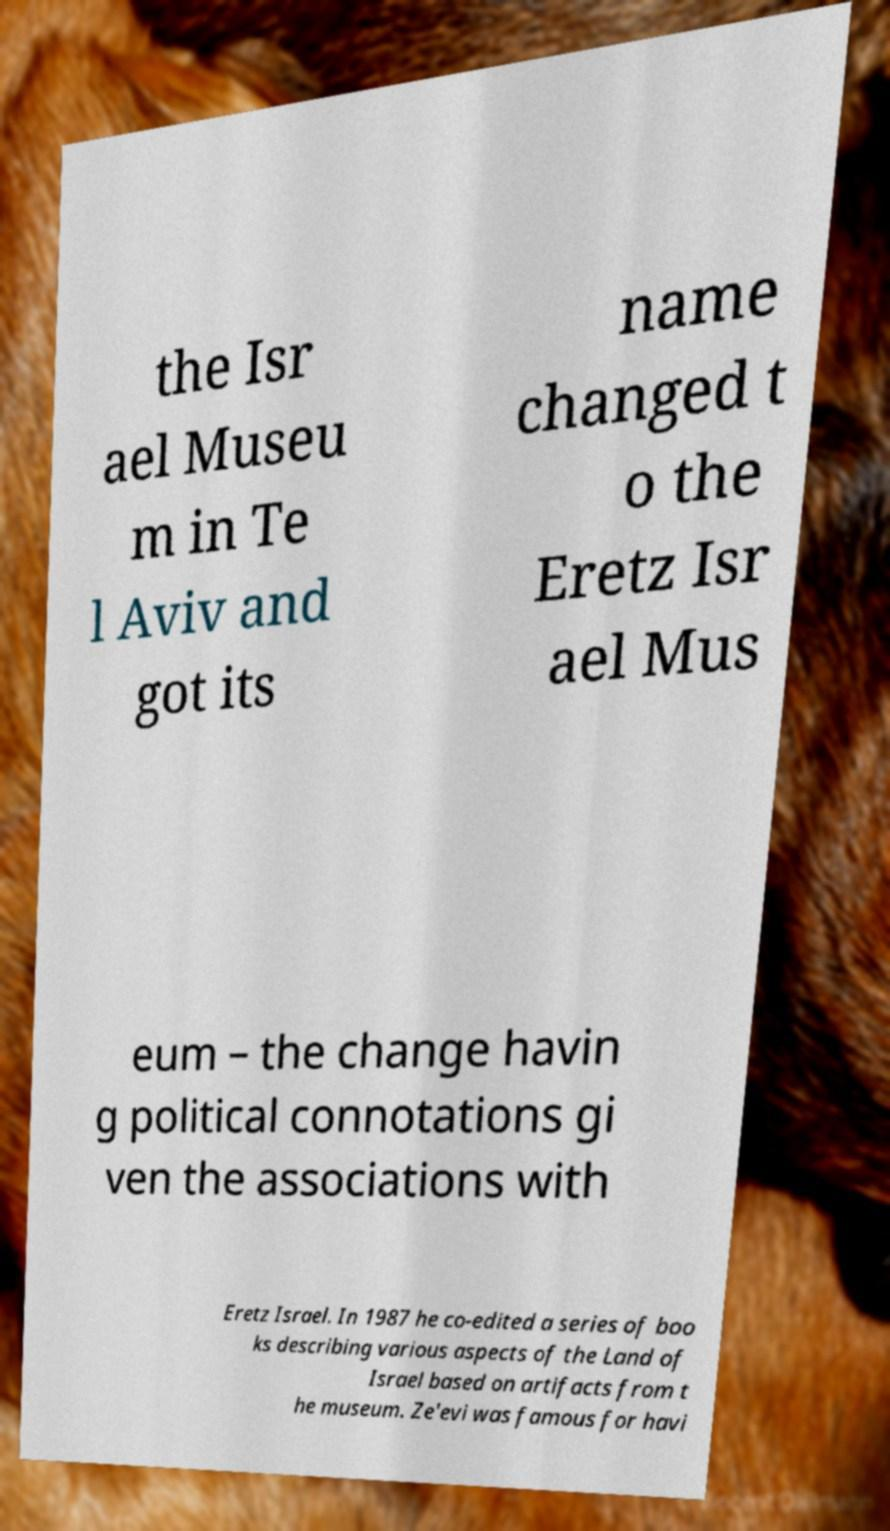Please read and relay the text visible in this image. What does it say? the Isr ael Museu m in Te l Aviv and got its name changed t o the Eretz Isr ael Mus eum – the change havin g political connotations gi ven the associations with Eretz Israel. In 1987 he co-edited a series of boo ks describing various aspects of the Land of Israel based on artifacts from t he museum. Ze'evi was famous for havi 